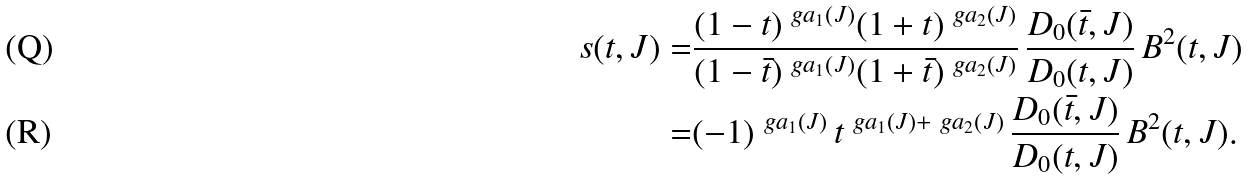Convert formula to latex. <formula><loc_0><loc_0><loc_500><loc_500>s ( t , J ) = & \frac { ( 1 - t ) ^ { \ g a _ { 1 } ( J ) } ( 1 + t ) ^ { \ g a _ { 2 } ( J ) } } { ( 1 - \bar { t } ) ^ { \ g a _ { 1 } ( J ) } ( 1 + \bar { t } ) ^ { \ g a _ { 2 } ( J ) } } \, \frac { D _ { 0 } ( \bar { t } , J ) } { D _ { 0 } ( t , J ) } \, B ^ { 2 } ( t , J ) \\ = & ( - 1 ) ^ { \ g a _ { 1 } ( J ) } \, t ^ { \ g a _ { 1 } ( J ) + \ g a _ { 2 } ( J ) } \, \frac { D _ { 0 } ( \bar { t } , J ) } { D _ { 0 } ( t , J ) } \, B ^ { 2 } ( t , J ) .</formula> 